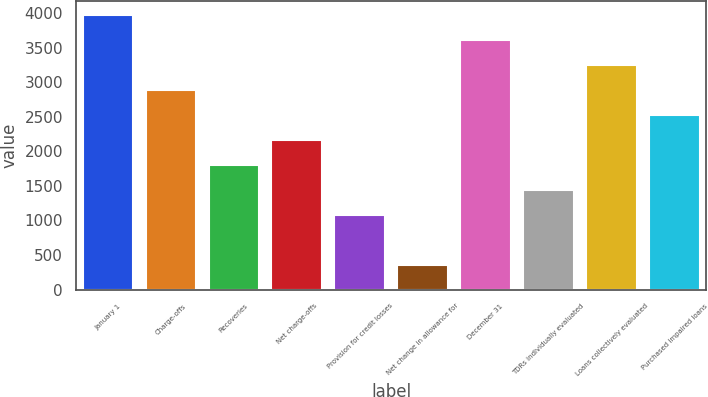<chart> <loc_0><loc_0><loc_500><loc_500><bar_chart><fcel>January 1<fcel>Charge-offs<fcel>Recoveries<fcel>Net charge-offs<fcel>Provision for credit losses<fcel>Net change in allowance for<fcel>December 31<fcel>TDRs individually evaluated<fcel>Loans collectively evaluated<fcel>Purchased impaired loans<nl><fcel>3969.77<fcel>2887.55<fcel>1805.33<fcel>2166.07<fcel>1083.85<fcel>362.37<fcel>3609.03<fcel>1444.59<fcel>3248.29<fcel>2526.81<nl></chart> 